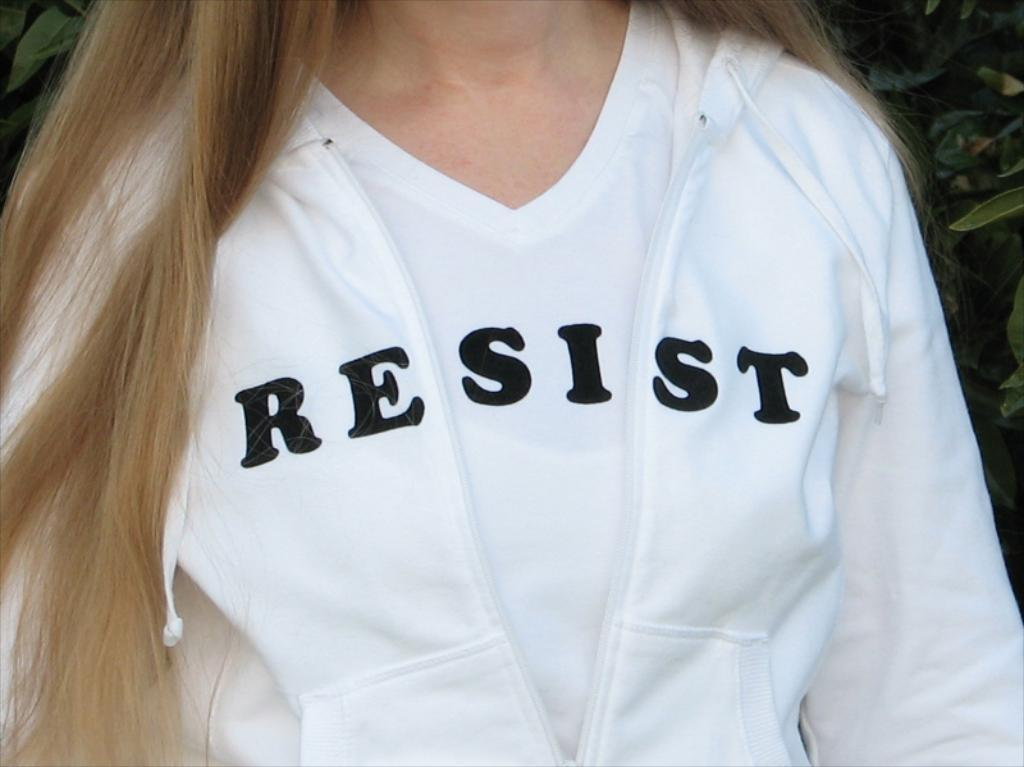Provide a one-sentence caption for the provided image. A woman is wearing a white jacket and shirt, combined together they spell the word resist. 